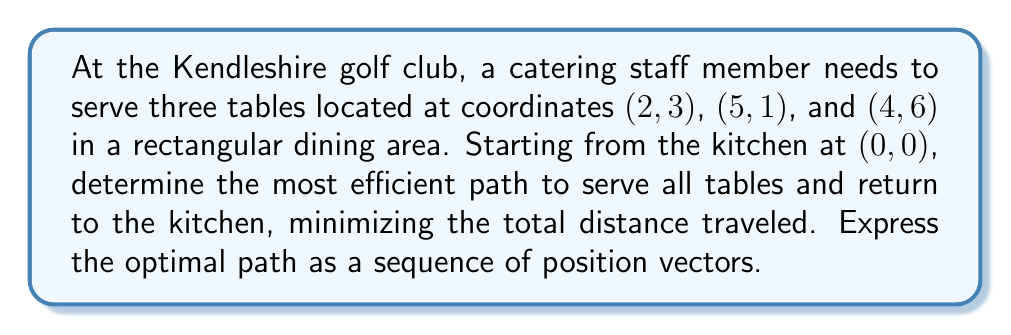Can you answer this question? To solve this problem, we'll use vector calculations to determine the most efficient path:

1) First, let's represent each location as a position vector:
   Kitchen: $\vec{k} = \begin{pmatrix} 0 \\ 0 \end{pmatrix}$
   Table 1: $\vec{t_1} = \begin{pmatrix} 2 \\ 3 \end{pmatrix}$
   Table 2: $\vec{t_2} = \begin{pmatrix} 5 \\ 1 \end{pmatrix}$
   Table 3: $\vec{t_3} = \begin{pmatrix} 4 \\ 6 \end{pmatrix}$

2) To find the most efficient path, we need to minimize the total distance traveled. This is equivalent to solving the Traveling Salesman Problem.

3) Calculate distances between all points:
   $d(k, t_1) = \sqrt{2^2 + 3^2} = \sqrt{13}$
   $d(k, t_2) = \sqrt{5^2 + 1^2} = \sqrt{26}$
   $d(k, t_3) = \sqrt{4^2 + 6^2} = \sqrt{52}$
   $d(t_1, t_2) = \sqrt{3^2 + (-2)^2} = \sqrt{13}$
   $d(t_1, t_3) = \sqrt{2^2 + 3^2} = \sqrt{13}$
   $d(t_2, t_3) = \sqrt{(-1)^2 + 5^2} = \sqrt{26}$

4) There are 3! = 6 possible paths. Let's calculate the total distance for each:
   k -> t1 -> t2 -> t3 -> k: $\sqrt{13} + \sqrt{13} + \sqrt{26} + \sqrt{52} \approx 18.60$
   k -> t1 -> t3 -> t2 -> k: $\sqrt{13} + \sqrt{13} + \sqrt{26} + \sqrt{26} \approx 17.46$
   k -> t2 -> t1 -> t3 -> k: $\sqrt{26} + \sqrt{13} + \sqrt{13} + \sqrt{52} \approx 18.60$
   k -> t2 -> t3 -> t1 -> k: $\sqrt{26} + \sqrt{26} + \sqrt{13} + \sqrt{13} \approx 17.46$
   k -> t3 -> t1 -> t2 -> k: $\sqrt{52} + \sqrt{13} + \sqrt{13} + \sqrt{26} \approx 18.60$
   k -> t3 -> t2 -> t1 -> k: $\sqrt{52} + \sqrt{26} + \sqrt{13} + \sqrt{13} \approx 18.60$

5) The minimum distance is achieved by two paths: k -> t1 -> t3 -> t2 -> k and k -> t2 -> t3 -> t1 -> k. We'll choose the first one.

6) Therefore, the optimal path in terms of position vectors is:
   $$\vec{k} \rightarrow \vec{t_1} \rightarrow \vec{t_3} \rightarrow \vec{t_2} \rightarrow \vec{k}$$
Answer: $\begin{pmatrix} 0 \\ 0 \end{pmatrix} \rightarrow \begin{pmatrix} 2 \\ 3 \end{pmatrix} \rightarrow \begin{pmatrix} 4 \\ 6 \end{pmatrix} \rightarrow \begin{pmatrix} 5 \\ 1 \end{pmatrix} \rightarrow \begin{pmatrix} 0 \\ 0 \end{pmatrix}$ 